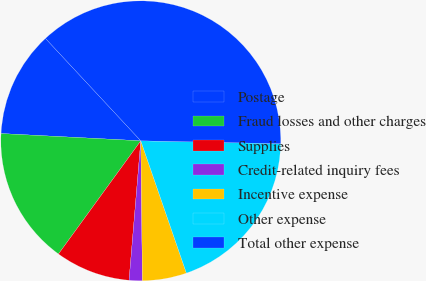<chart> <loc_0><loc_0><loc_500><loc_500><pie_chart><fcel>Postage<fcel>Fraud losses and other charges<fcel>Supplies<fcel>Credit-related inquiry fees<fcel>Incentive expense<fcel>Other expense<fcel>Total other expense<nl><fcel>12.24%<fcel>15.82%<fcel>8.67%<fcel>1.52%<fcel>5.1%<fcel>19.39%<fcel>37.26%<nl></chart> 